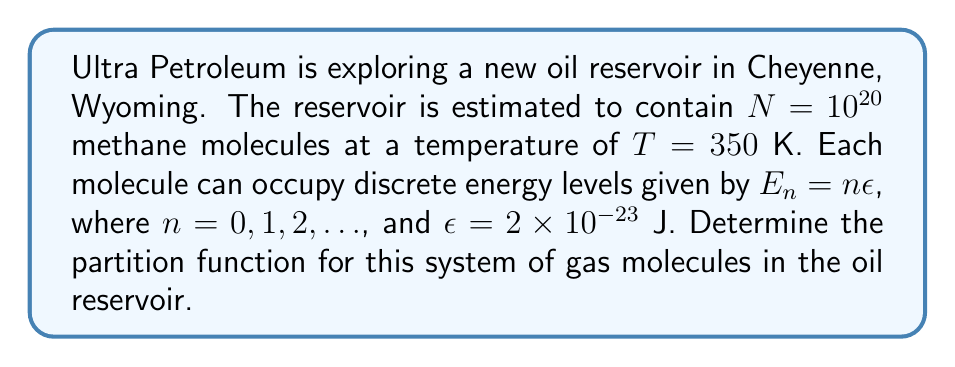Show me your answer to this math problem. To determine the partition function for this system, we'll follow these steps:

1) The partition function $Z$ for a single molecule is given by:

   $$Z_1 = \sum_{n=0}^{\infty} e^{-\beta E_n}$$

   where $\beta = \frac{1}{k_B T}$, and $k_B$ is the Boltzmann constant.

2) Substituting $E_n = n\epsilon$:

   $$Z_1 = \sum_{n=0}^{\infty} e^{-\beta n\epsilon}$$

3) This is a geometric series with first term 1 and common ratio $e^{-\beta\epsilon}$. The sum of this infinite geometric series is:

   $$Z_1 = \frac{1}{1 - e^{-\beta\epsilon}}$$

4) Calculate $\beta$:
   $\beta = \frac{1}{k_B T} = \frac{1}{(1.38 \times 10^{-23} \text{ J/K})(350 \text{ K})} = 2.07 \times 10^{20} \text{ J}^{-1}$

5) Calculate $\beta\epsilon$:
   $\beta\epsilon = (2.07 \times 10^{20} \text{ J}^{-1})(2 \times 10^{-23} \text{ J}) = 4.14$

6) Now we can calculate $Z_1$:

   $$Z_1 = \frac{1}{1 - e^{-4.14}} = 1.016$$

7) For a system of $N$ independent particles, the total partition function is:

   $$Z = (Z_1)^N$$

8) Therefore, the final partition function for the system is:

   $$Z = (1.016)^{10^{20}}$$
Answer: $Z = (1.016)^{10^{20}}$ 